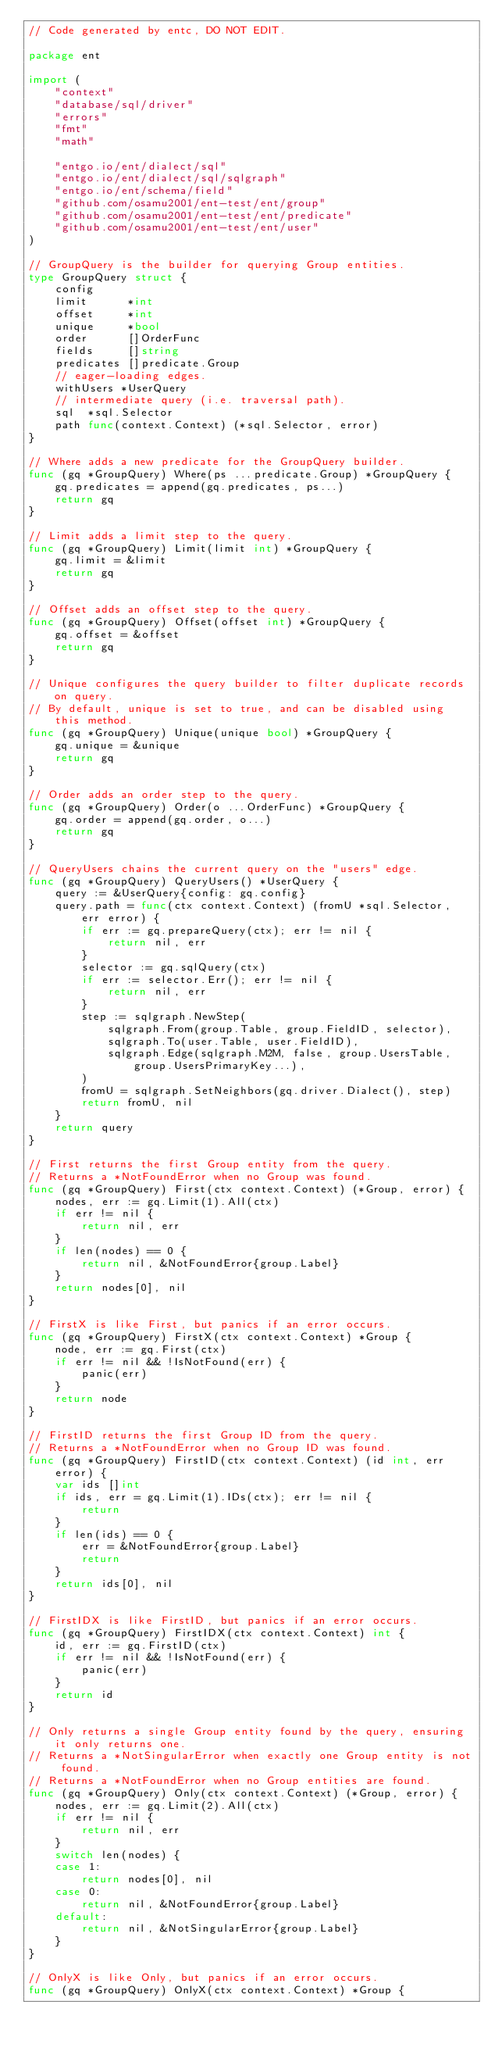<code> <loc_0><loc_0><loc_500><loc_500><_Go_>// Code generated by entc, DO NOT EDIT.

package ent

import (
	"context"
	"database/sql/driver"
	"errors"
	"fmt"
	"math"

	"entgo.io/ent/dialect/sql"
	"entgo.io/ent/dialect/sql/sqlgraph"
	"entgo.io/ent/schema/field"
	"github.com/osamu2001/ent-test/ent/group"
	"github.com/osamu2001/ent-test/ent/predicate"
	"github.com/osamu2001/ent-test/ent/user"
)

// GroupQuery is the builder for querying Group entities.
type GroupQuery struct {
	config
	limit      *int
	offset     *int
	unique     *bool
	order      []OrderFunc
	fields     []string
	predicates []predicate.Group
	// eager-loading edges.
	withUsers *UserQuery
	// intermediate query (i.e. traversal path).
	sql  *sql.Selector
	path func(context.Context) (*sql.Selector, error)
}

// Where adds a new predicate for the GroupQuery builder.
func (gq *GroupQuery) Where(ps ...predicate.Group) *GroupQuery {
	gq.predicates = append(gq.predicates, ps...)
	return gq
}

// Limit adds a limit step to the query.
func (gq *GroupQuery) Limit(limit int) *GroupQuery {
	gq.limit = &limit
	return gq
}

// Offset adds an offset step to the query.
func (gq *GroupQuery) Offset(offset int) *GroupQuery {
	gq.offset = &offset
	return gq
}

// Unique configures the query builder to filter duplicate records on query.
// By default, unique is set to true, and can be disabled using this method.
func (gq *GroupQuery) Unique(unique bool) *GroupQuery {
	gq.unique = &unique
	return gq
}

// Order adds an order step to the query.
func (gq *GroupQuery) Order(o ...OrderFunc) *GroupQuery {
	gq.order = append(gq.order, o...)
	return gq
}

// QueryUsers chains the current query on the "users" edge.
func (gq *GroupQuery) QueryUsers() *UserQuery {
	query := &UserQuery{config: gq.config}
	query.path = func(ctx context.Context) (fromU *sql.Selector, err error) {
		if err := gq.prepareQuery(ctx); err != nil {
			return nil, err
		}
		selector := gq.sqlQuery(ctx)
		if err := selector.Err(); err != nil {
			return nil, err
		}
		step := sqlgraph.NewStep(
			sqlgraph.From(group.Table, group.FieldID, selector),
			sqlgraph.To(user.Table, user.FieldID),
			sqlgraph.Edge(sqlgraph.M2M, false, group.UsersTable, group.UsersPrimaryKey...),
		)
		fromU = sqlgraph.SetNeighbors(gq.driver.Dialect(), step)
		return fromU, nil
	}
	return query
}

// First returns the first Group entity from the query.
// Returns a *NotFoundError when no Group was found.
func (gq *GroupQuery) First(ctx context.Context) (*Group, error) {
	nodes, err := gq.Limit(1).All(ctx)
	if err != nil {
		return nil, err
	}
	if len(nodes) == 0 {
		return nil, &NotFoundError{group.Label}
	}
	return nodes[0], nil
}

// FirstX is like First, but panics if an error occurs.
func (gq *GroupQuery) FirstX(ctx context.Context) *Group {
	node, err := gq.First(ctx)
	if err != nil && !IsNotFound(err) {
		panic(err)
	}
	return node
}

// FirstID returns the first Group ID from the query.
// Returns a *NotFoundError when no Group ID was found.
func (gq *GroupQuery) FirstID(ctx context.Context) (id int, err error) {
	var ids []int
	if ids, err = gq.Limit(1).IDs(ctx); err != nil {
		return
	}
	if len(ids) == 0 {
		err = &NotFoundError{group.Label}
		return
	}
	return ids[0], nil
}

// FirstIDX is like FirstID, but panics if an error occurs.
func (gq *GroupQuery) FirstIDX(ctx context.Context) int {
	id, err := gq.FirstID(ctx)
	if err != nil && !IsNotFound(err) {
		panic(err)
	}
	return id
}

// Only returns a single Group entity found by the query, ensuring it only returns one.
// Returns a *NotSingularError when exactly one Group entity is not found.
// Returns a *NotFoundError when no Group entities are found.
func (gq *GroupQuery) Only(ctx context.Context) (*Group, error) {
	nodes, err := gq.Limit(2).All(ctx)
	if err != nil {
		return nil, err
	}
	switch len(nodes) {
	case 1:
		return nodes[0], nil
	case 0:
		return nil, &NotFoundError{group.Label}
	default:
		return nil, &NotSingularError{group.Label}
	}
}

// OnlyX is like Only, but panics if an error occurs.
func (gq *GroupQuery) OnlyX(ctx context.Context) *Group {</code> 